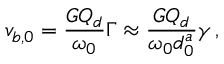Convert formula to latex. <formula><loc_0><loc_0><loc_500><loc_500>v _ { b , 0 } = \frac { G Q _ { d } } { \omega _ { 0 } } \Gamma \approx \frac { G Q _ { d } } { \omega _ { 0 } d _ { 0 } ^ { a } } \gamma \, ,</formula> 